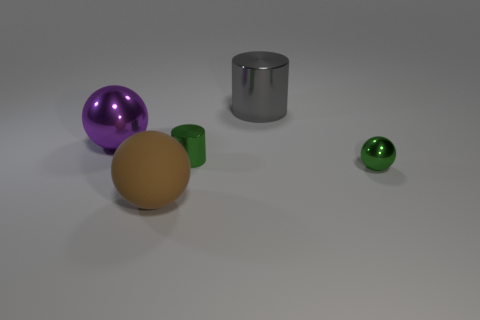Is there a large purple ball that has the same material as the large gray cylinder?
Provide a short and direct response. Yes. There is a big purple shiny object; is it the same shape as the small green thing that is in front of the small cylinder?
Offer a terse response. Yes. Are there any big brown things in front of the green sphere?
Your answer should be compact. Yes. What number of metallic objects are the same shape as the brown matte object?
Your response must be concise. 2. Are the tiny ball and the large brown sphere that is to the left of the tiny ball made of the same material?
Keep it short and to the point. No. What number of large shiny balls are there?
Your answer should be compact. 1. What is the size of the purple shiny ball behind the rubber thing?
Offer a terse response. Large. What number of green cubes are the same size as the brown matte sphere?
Give a very brief answer. 0. What is the ball that is behind the big brown matte object and to the left of the green ball made of?
Your answer should be very brief. Metal. There is a purple sphere that is the same size as the rubber object; what is it made of?
Offer a very short reply. Metal. 